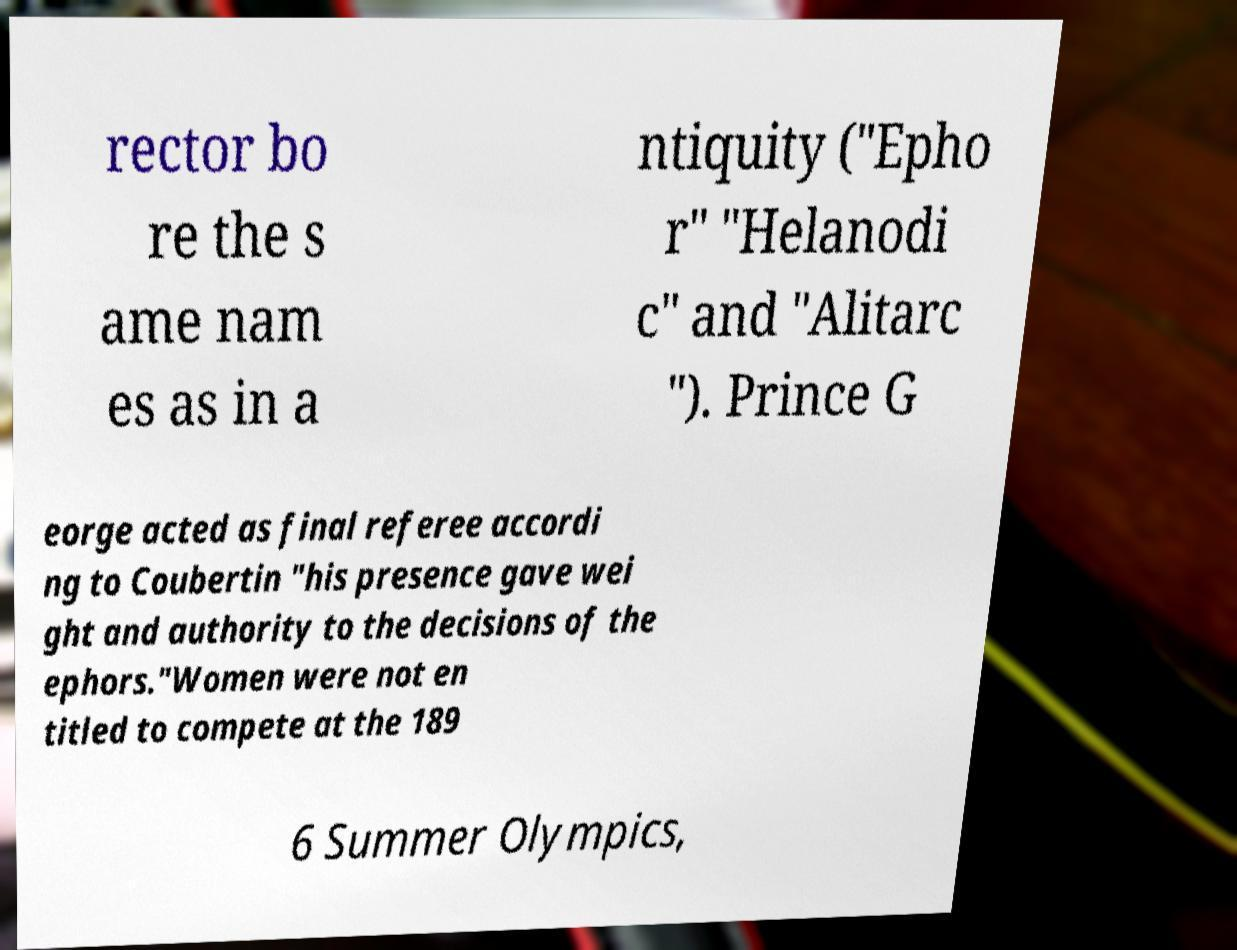Please identify and transcribe the text found in this image. rector bo re the s ame nam es as in a ntiquity ("Epho r" "Helanodi c" and "Alitarc "). Prince G eorge acted as final referee accordi ng to Coubertin "his presence gave wei ght and authority to the decisions of the ephors."Women were not en titled to compete at the 189 6 Summer Olympics, 